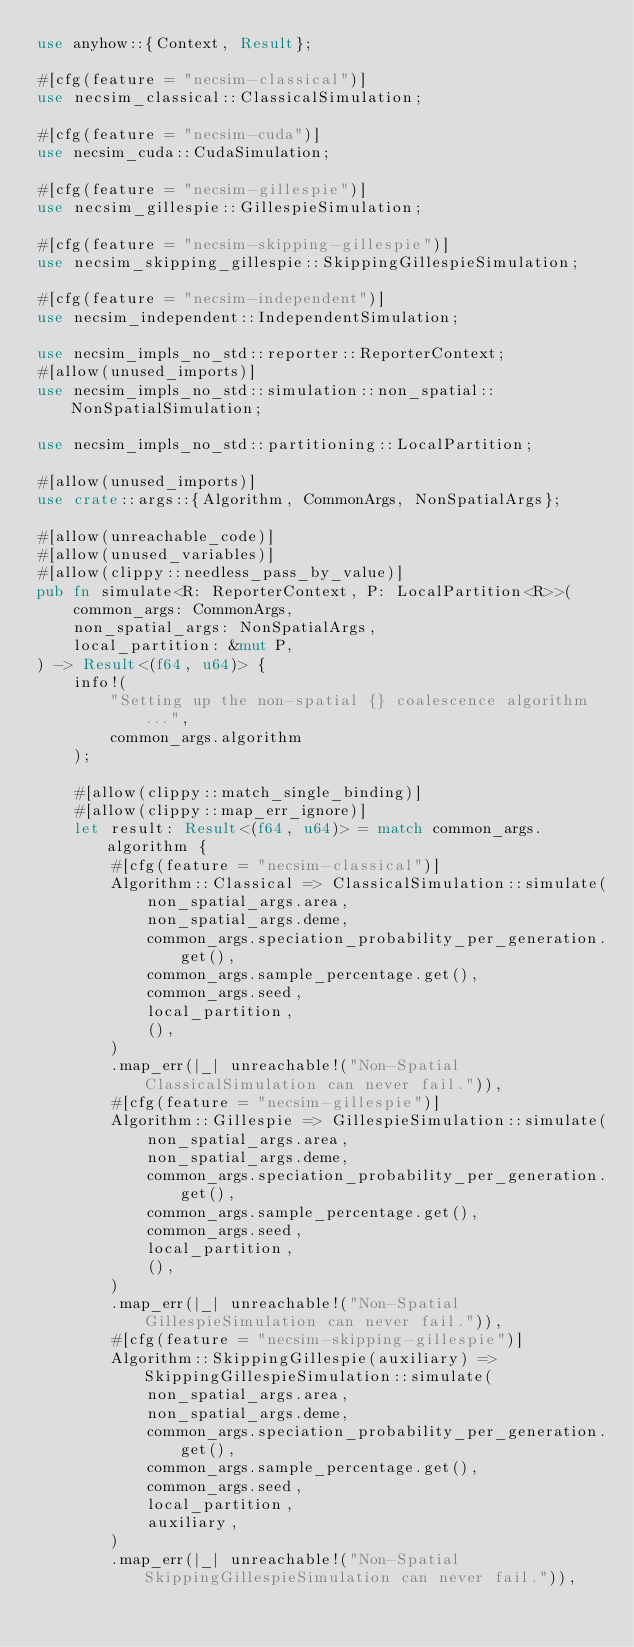<code> <loc_0><loc_0><loc_500><loc_500><_Rust_>use anyhow::{Context, Result};

#[cfg(feature = "necsim-classical")]
use necsim_classical::ClassicalSimulation;

#[cfg(feature = "necsim-cuda")]
use necsim_cuda::CudaSimulation;

#[cfg(feature = "necsim-gillespie")]
use necsim_gillespie::GillespieSimulation;

#[cfg(feature = "necsim-skipping-gillespie")]
use necsim_skipping_gillespie::SkippingGillespieSimulation;

#[cfg(feature = "necsim-independent")]
use necsim_independent::IndependentSimulation;

use necsim_impls_no_std::reporter::ReporterContext;
#[allow(unused_imports)]
use necsim_impls_no_std::simulation::non_spatial::NonSpatialSimulation;

use necsim_impls_no_std::partitioning::LocalPartition;

#[allow(unused_imports)]
use crate::args::{Algorithm, CommonArgs, NonSpatialArgs};

#[allow(unreachable_code)]
#[allow(unused_variables)]
#[allow(clippy::needless_pass_by_value)]
pub fn simulate<R: ReporterContext, P: LocalPartition<R>>(
    common_args: CommonArgs,
    non_spatial_args: NonSpatialArgs,
    local_partition: &mut P,
) -> Result<(f64, u64)> {
    info!(
        "Setting up the non-spatial {} coalescence algorithm ...",
        common_args.algorithm
    );

    #[allow(clippy::match_single_binding)]
    #[allow(clippy::map_err_ignore)]
    let result: Result<(f64, u64)> = match common_args.algorithm {
        #[cfg(feature = "necsim-classical")]
        Algorithm::Classical => ClassicalSimulation::simulate(
            non_spatial_args.area,
            non_spatial_args.deme,
            common_args.speciation_probability_per_generation.get(),
            common_args.sample_percentage.get(),
            common_args.seed,
            local_partition,
            (),
        )
        .map_err(|_| unreachable!("Non-Spatial ClassicalSimulation can never fail.")),
        #[cfg(feature = "necsim-gillespie")]
        Algorithm::Gillespie => GillespieSimulation::simulate(
            non_spatial_args.area,
            non_spatial_args.deme,
            common_args.speciation_probability_per_generation.get(),
            common_args.sample_percentage.get(),
            common_args.seed,
            local_partition,
            (),
        )
        .map_err(|_| unreachable!("Non-Spatial GillespieSimulation can never fail.")),
        #[cfg(feature = "necsim-skipping-gillespie")]
        Algorithm::SkippingGillespie(auxiliary) => SkippingGillespieSimulation::simulate(
            non_spatial_args.area,
            non_spatial_args.deme,
            common_args.speciation_probability_per_generation.get(),
            common_args.sample_percentage.get(),
            common_args.seed,
            local_partition,
            auxiliary,
        )
        .map_err(|_| unreachable!("Non-Spatial SkippingGillespieSimulation can never fail.")),</code> 